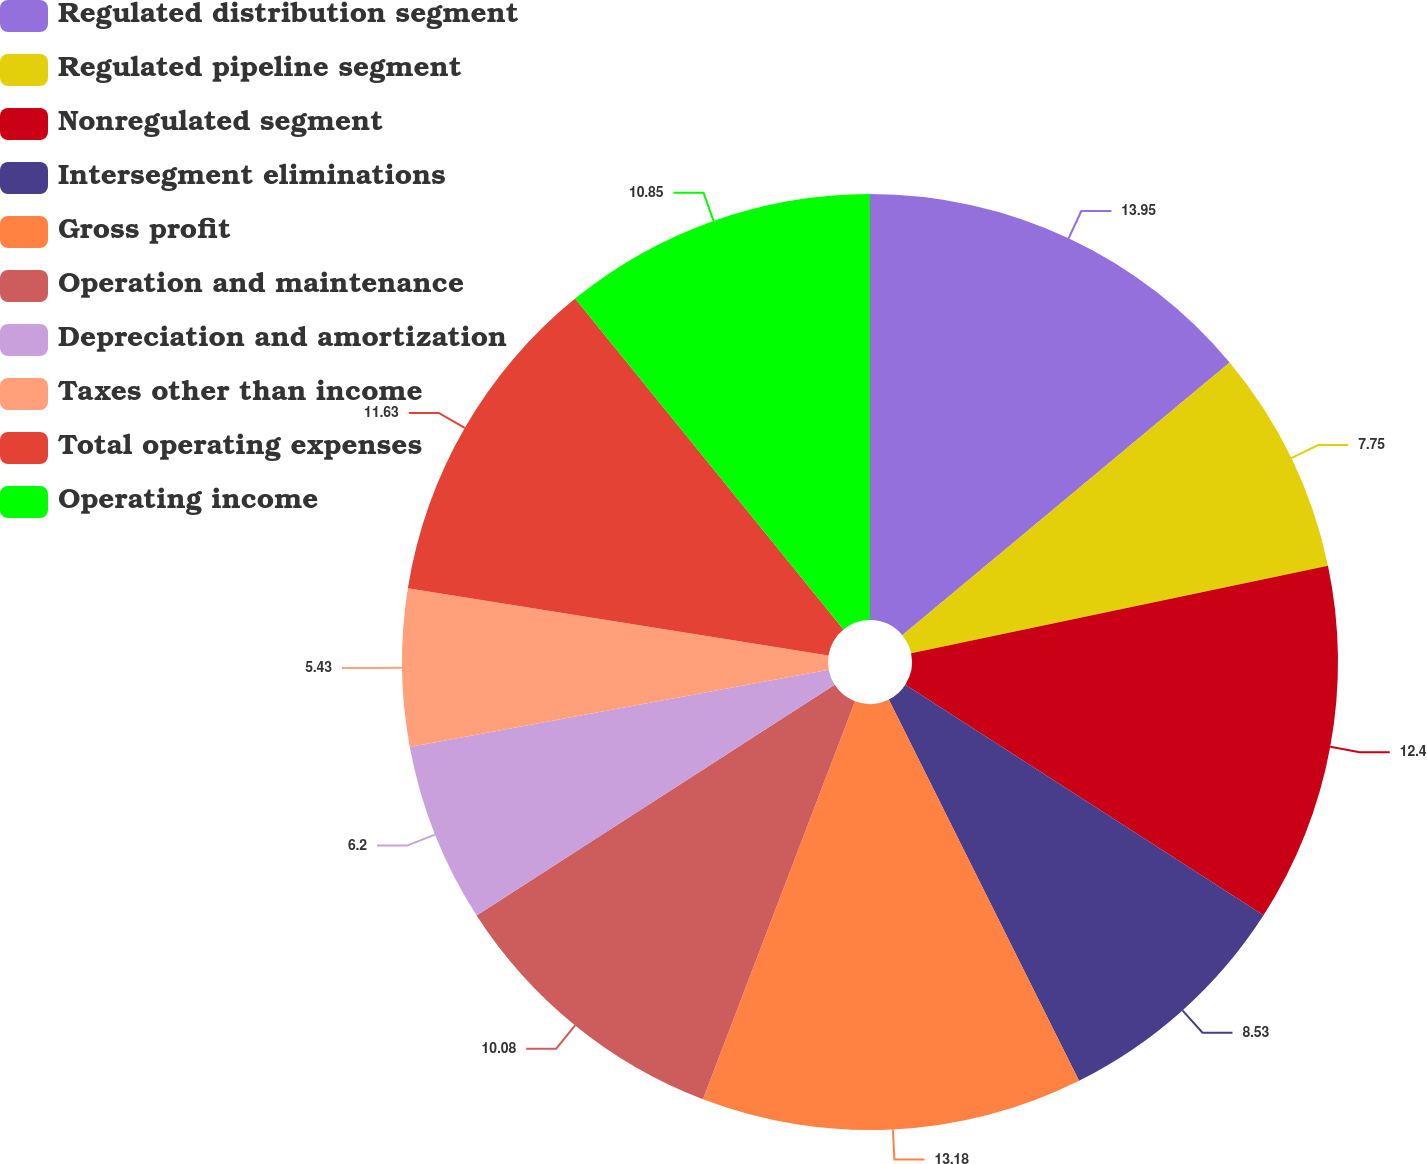<chart> <loc_0><loc_0><loc_500><loc_500><pie_chart><fcel>Regulated distribution segment<fcel>Regulated pipeline segment<fcel>Nonregulated segment<fcel>Intersegment eliminations<fcel>Gross profit<fcel>Operation and maintenance<fcel>Depreciation and amortization<fcel>Taxes other than income<fcel>Total operating expenses<fcel>Operating income<nl><fcel>13.95%<fcel>7.75%<fcel>12.4%<fcel>8.53%<fcel>13.18%<fcel>10.08%<fcel>6.2%<fcel>5.43%<fcel>11.63%<fcel>10.85%<nl></chart> 